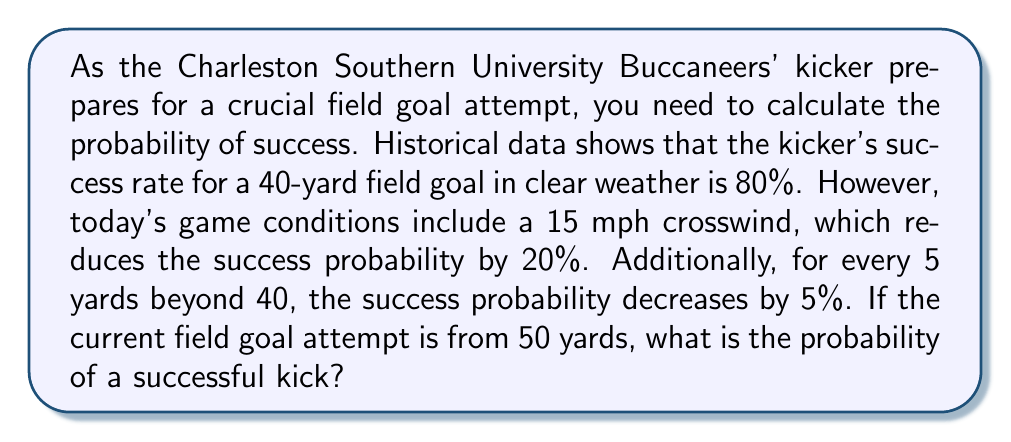Provide a solution to this math problem. Let's break this down step-by-step:

1) First, we need to calculate the base probability for a 50-yard field goal in clear weather:
   - The base rate is 80% for a 40-yard field goal
   - The kick is 10 yards further than 40 yards
   - For every 5 yards, the probability decreases by 5%
   - So for 10 yards, it decreases by 10%
   
   $$P_{50yd} = 80\% - 10\% = 70\%$$

2) Now, we need to account for the crosswind:
   - The crosswind reduces the probability by 20%
   - This is a multiplicative factor, not additive

   $$P_{wind} = 70\% \times (1 - 0.20) = 70\% \times 0.80 = 56\%$$

3) Convert the percentage to a decimal:

   $$P_{final} = 0.56$$

Therefore, the probability of a successful 50-yard field goal attempt in these conditions is 0.56 or 56%.
Answer: 0.56 